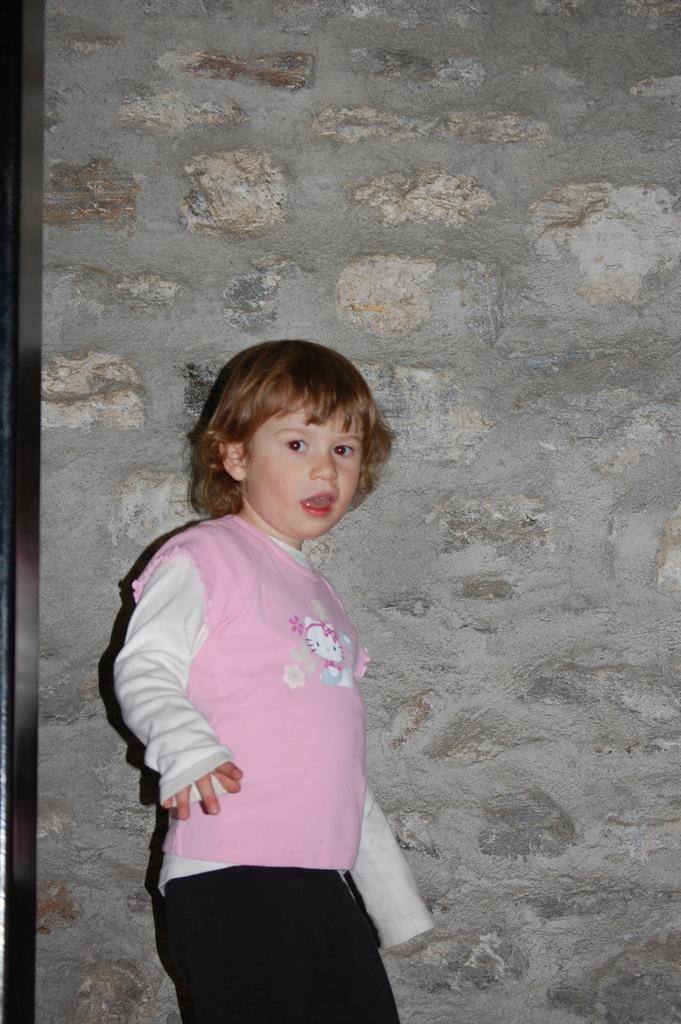Who is the main subject in the image? There is a boy in the image. What is the boy doing in the image? The boy is standing. What is the boy wearing in the image? The boy is wearing a pink sweater and black pants. What can be seen in the background of the image? There is a wall in the background of the image. What type of pear is the boy holding in the image? There is no pear present in the image; the boy is not holding any fruit. Why is the boy crying in the image? The boy is not crying in the image; he is standing and not displaying any signs of distress. 